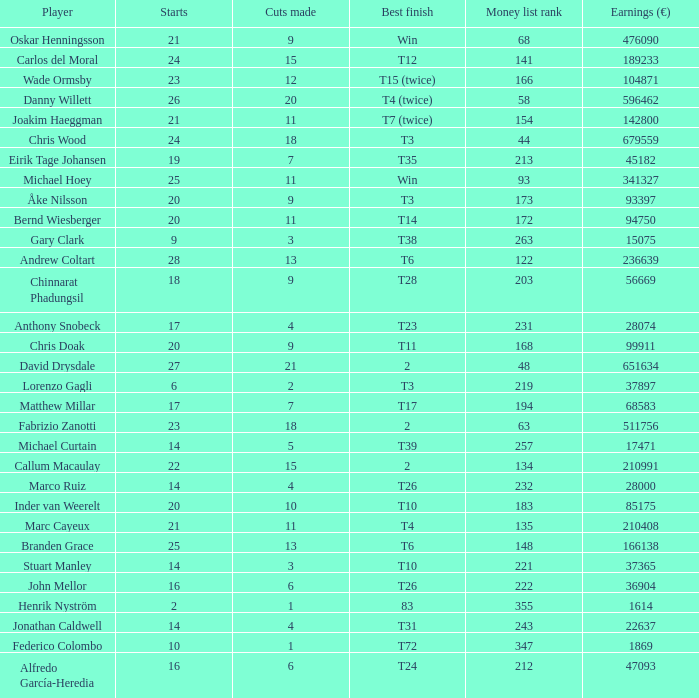How many times did bernd wiesberger manage to make cuts? 11.0. 